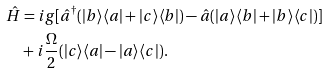Convert formula to latex. <formula><loc_0><loc_0><loc_500><loc_500>\hat { H } & = i g [ \hat { a } ^ { \dagger } ( | b \rangle \langle a | + | c \rangle \langle b | ) - \hat { a } ( | a \rangle \langle b | + | b \rangle \langle c | ) ] \\ & + i \frac { \Omega } { 2 } ( | c \rangle \langle a | - | a \rangle \langle c | ) .</formula> 